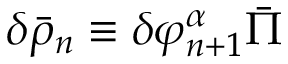Convert formula to latex. <formula><loc_0><loc_0><loc_500><loc_500>\delta \bar { \rho } _ { n } \equiv \delta \varphi _ { n + 1 } ^ { \alpha } \bar { \Pi }</formula> 